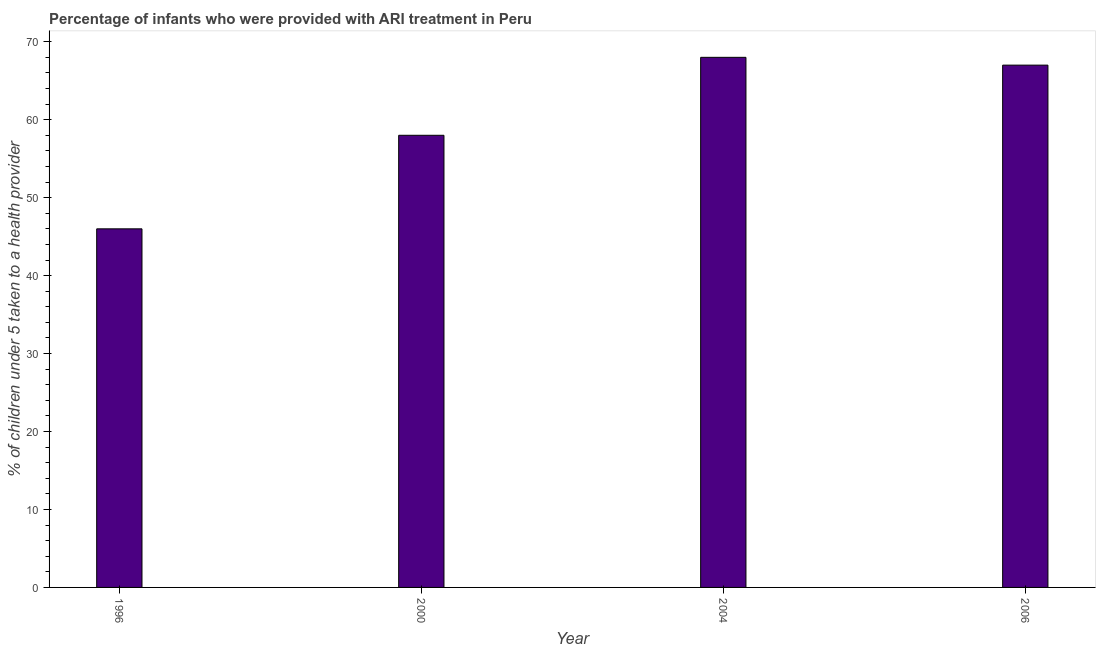Does the graph contain any zero values?
Your answer should be very brief. No. Does the graph contain grids?
Your answer should be very brief. No. What is the title of the graph?
Keep it short and to the point. Percentage of infants who were provided with ARI treatment in Peru. What is the label or title of the X-axis?
Your answer should be very brief. Year. What is the label or title of the Y-axis?
Offer a very short reply. % of children under 5 taken to a health provider. Across all years, what is the minimum percentage of children who were provided with ari treatment?
Provide a short and direct response. 46. In which year was the percentage of children who were provided with ari treatment maximum?
Your response must be concise. 2004. In which year was the percentage of children who were provided with ari treatment minimum?
Make the answer very short. 1996. What is the sum of the percentage of children who were provided with ari treatment?
Make the answer very short. 239. What is the average percentage of children who were provided with ari treatment per year?
Offer a very short reply. 59.75. What is the median percentage of children who were provided with ari treatment?
Provide a succinct answer. 62.5. Do a majority of the years between 2000 and 2006 (inclusive) have percentage of children who were provided with ari treatment greater than 44 %?
Provide a short and direct response. Yes. What is the ratio of the percentage of children who were provided with ari treatment in 2000 to that in 2004?
Keep it short and to the point. 0.85. Is the difference between the percentage of children who were provided with ari treatment in 2004 and 2006 greater than the difference between any two years?
Offer a very short reply. No. What is the difference between the highest and the second highest percentage of children who were provided with ari treatment?
Keep it short and to the point. 1. How many bars are there?
Offer a very short reply. 4. How many years are there in the graph?
Offer a terse response. 4. What is the % of children under 5 taken to a health provider of 1996?
Offer a terse response. 46. What is the % of children under 5 taken to a health provider of 2000?
Keep it short and to the point. 58. What is the % of children under 5 taken to a health provider in 2004?
Give a very brief answer. 68. What is the difference between the % of children under 5 taken to a health provider in 1996 and 2000?
Your response must be concise. -12. What is the difference between the % of children under 5 taken to a health provider in 1996 and 2004?
Offer a very short reply. -22. What is the difference between the % of children under 5 taken to a health provider in 1996 and 2006?
Your response must be concise. -21. What is the difference between the % of children under 5 taken to a health provider in 2000 and 2004?
Make the answer very short. -10. What is the ratio of the % of children under 5 taken to a health provider in 1996 to that in 2000?
Keep it short and to the point. 0.79. What is the ratio of the % of children under 5 taken to a health provider in 1996 to that in 2004?
Make the answer very short. 0.68. What is the ratio of the % of children under 5 taken to a health provider in 1996 to that in 2006?
Ensure brevity in your answer.  0.69. What is the ratio of the % of children under 5 taken to a health provider in 2000 to that in 2004?
Offer a very short reply. 0.85. What is the ratio of the % of children under 5 taken to a health provider in 2000 to that in 2006?
Keep it short and to the point. 0.87. 